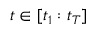<formula> <loc_0><loc_0><loc_500><loc_500>t \in [ t _ { 1 } \colon t _ { T } ]</formula> 